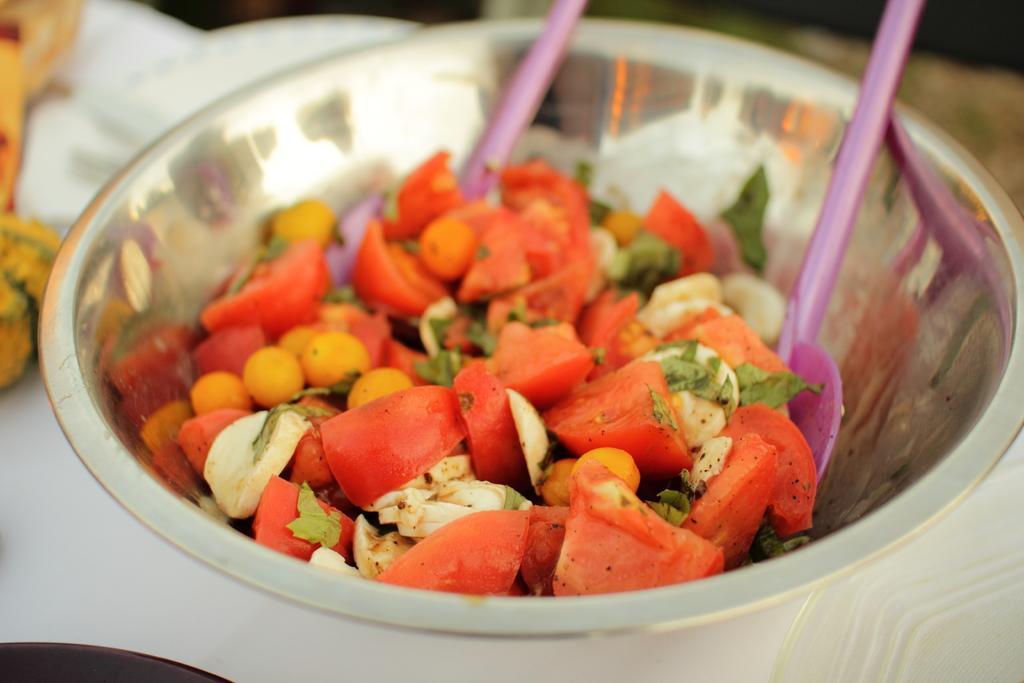In one or two sentences, can you explain what this image depicts? In this image we can see some food with spoons in a bowl which is placed on the table. 